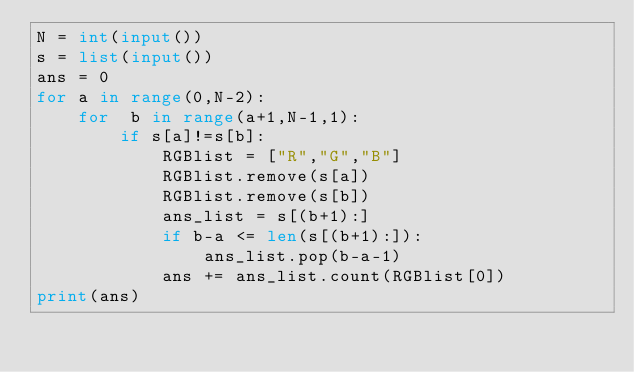Convert code to text. <code><loc_0><loc_0><loc_500><loc_500><_Python_>N = int(input())
s = list(input())
ans = 0
for a in range(0,N-2):
    for  b in range(a+1,N-1,1):
        if s[a]!=s[b]:
            RGBlist = ["R","G","B"]
            RGBlist.remove(s[a])
            RGBlist.remove(s[b])
            ans_list = s[(b+1):]
            if b-a <= len(s[(b+1):]):
                ans_list.pop(b-a-1)
            ans += ans_list.count(RGBlist[0])
print(ans)
</code> 